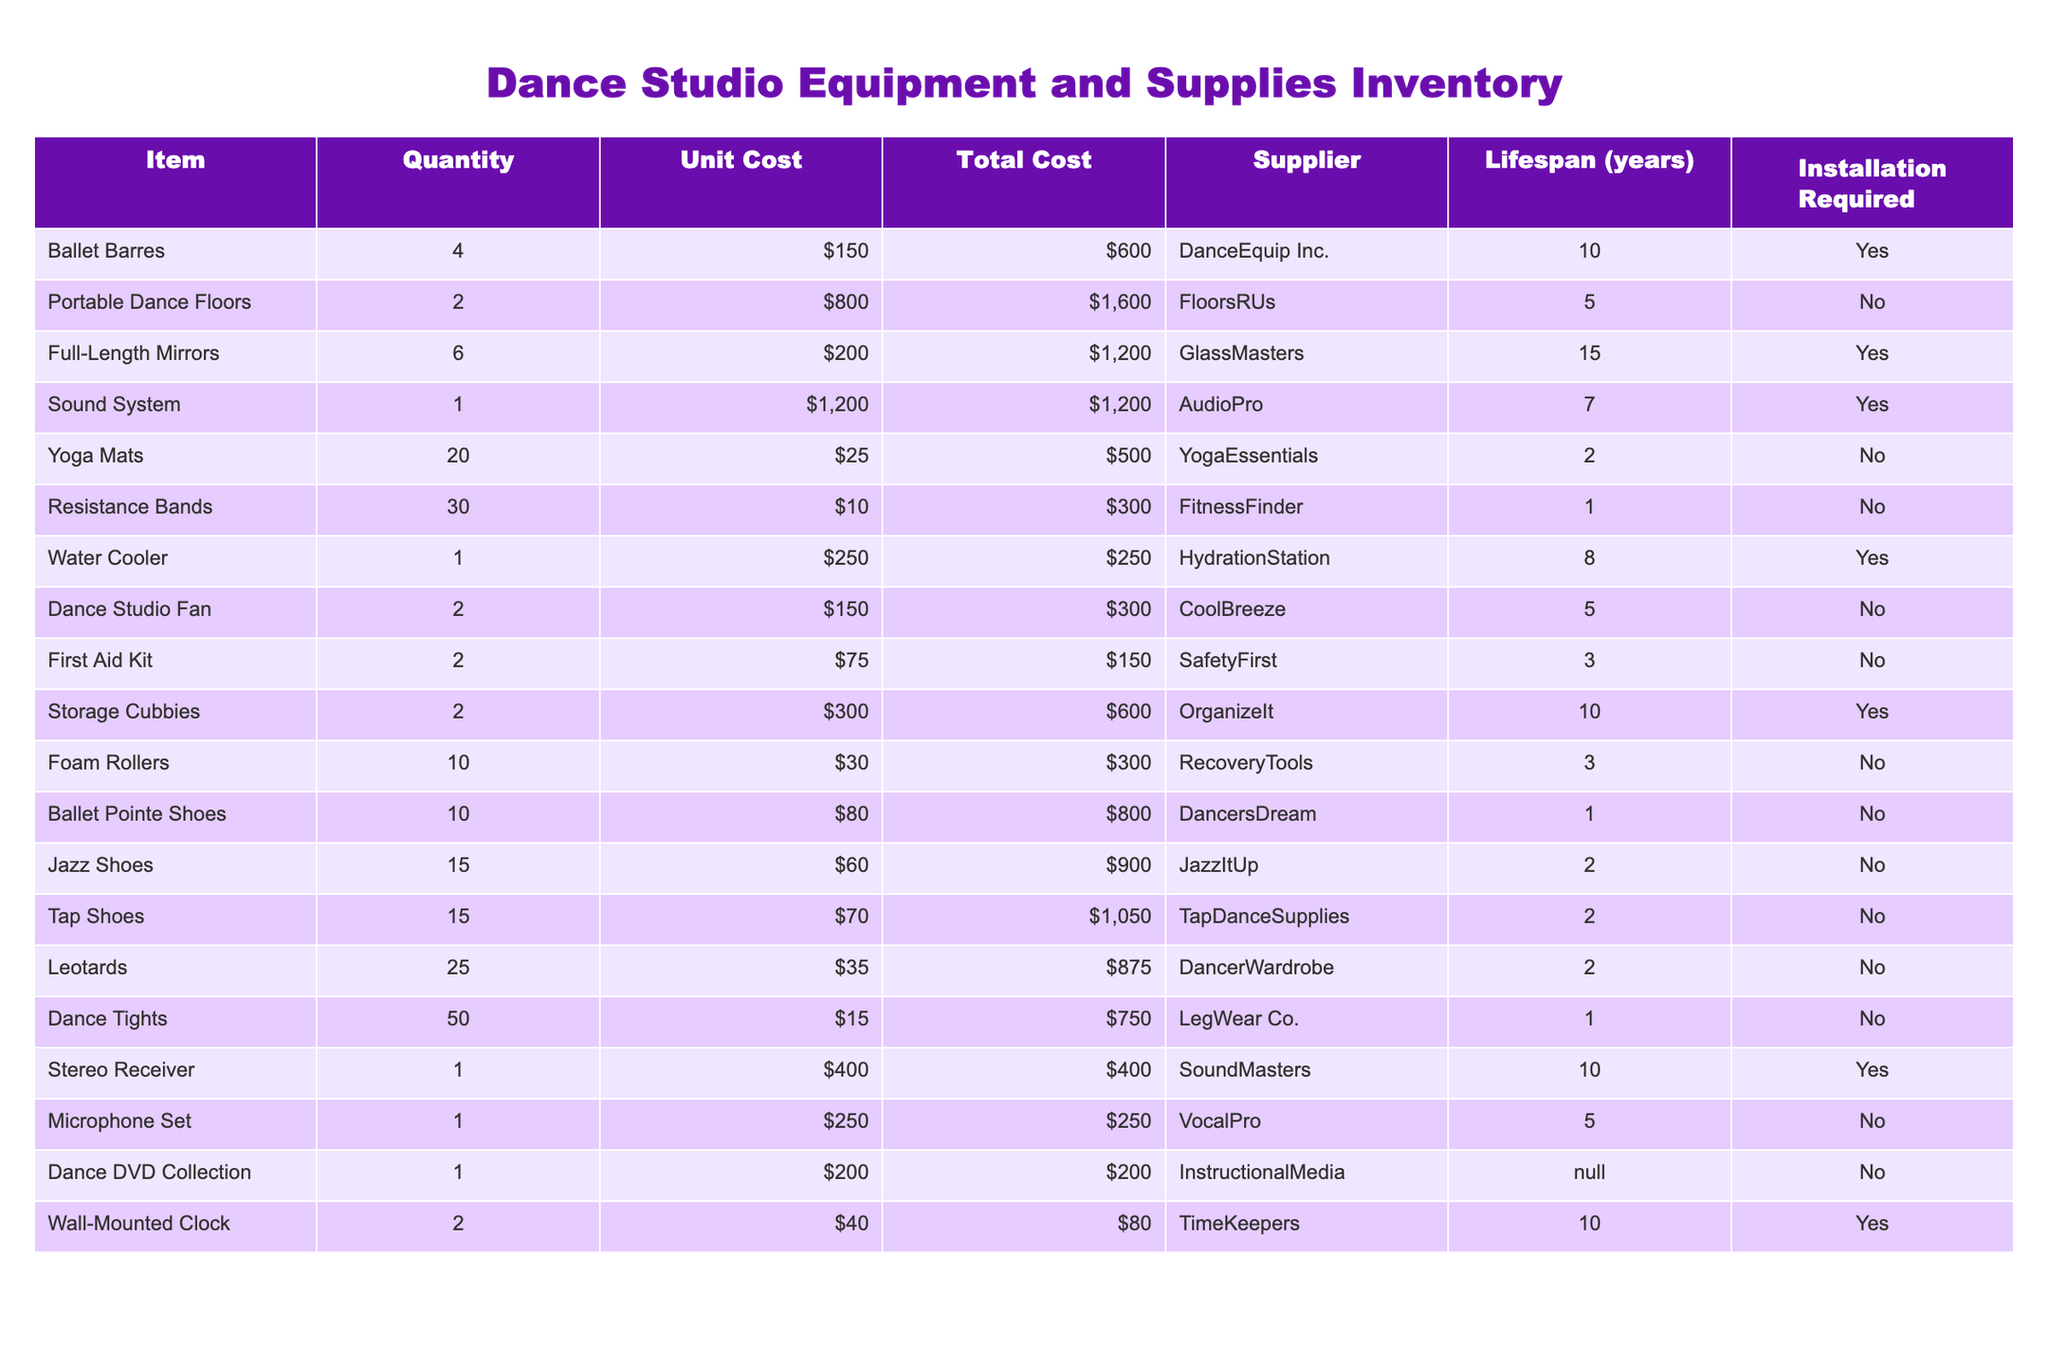What is the total cost of the Ballet Barres? The total cost for Ballet Barres is listed in the "Total Cost" column next to the item. It shows $600.
Answer: $600 How many items in the inventory require installation? To find this, we check the "Installation Required" column for 'Yes'. There are 6 items that require installation.
Answer: 6 What is the total cost for all items combined? We calculate the total by summing all values in the "Total Cost" column. The sum is $600 + $1600 + $1200 + $1200 + $500 + $300 + $250 + $300 + $150 + $600 + $300 + $800 + $900 + $1050 + $875 + $750 + $400 + $250 + $200 + $80 = $11,855.
Answer: $11,855 Which item has the longest lifespan? We look at the "Lifespan (years)" column and identify which item has the highest value; Full-Length Mirrors have a lifespan of 15 years.
Answer: Full-Length Mirrors What is the average unit cost of the footwear items (Ballet Pointe Shoes, Jazz Shoes, Tap Shoes, Leotards, and Dance Tights)? The unit costs are $80, $60, $70, $35, and $15, respectively. We sum these (80 + 60 + 70 + 35 + 15 = 260) and divide by 5, yielding an average of 260/5 = $52.
Answer: $52 How much do the Yoga Mats cost in total? The total cost of Yoga Mats is displayed under "Total Cost," which is $500.
Answer: $500 Is the Water Cooler the only item with a lifespan of 8 years? We check the "Lifespan (years)" column for any other items with the same lifespan. The Water Cooler is the only item listed with a lifespan of 8 years.
Answer: Yes How many items have a unit cost above $200? We examine the "Unit Cost" column and count items with costs exceeding $200: Full-Length Mirrors ($200), Sound System ($1200), and Storage Cubbies ($300). There are 3 items.
Answer: 3 What is the total cost for items that do not require installation? Identify items marked 'No' in the "Installation Required" column and sum their total costs: $500 (Yoga Mats) + $300 (Resistance Bands) + $150 (First Aid Kit) + $300 (Foam Rollers) + $800 (Ballet Pointe Shoes) + $900 (Jazz Shoes) + $1050 (Tap Shoes) + $875 (Leotards) + $750 (Dance Tights) + $250 (Microphone Set) + $200 (Dance DVD Collection) = $5,125.
Answer: $5,125 How many different types of shoes are listed in the inventory? We look specifically at the footwear items. There are 3 types: Ballet Pointe Shoes, Jazz Shoes, and Tap Shoes.
Answer: 3 